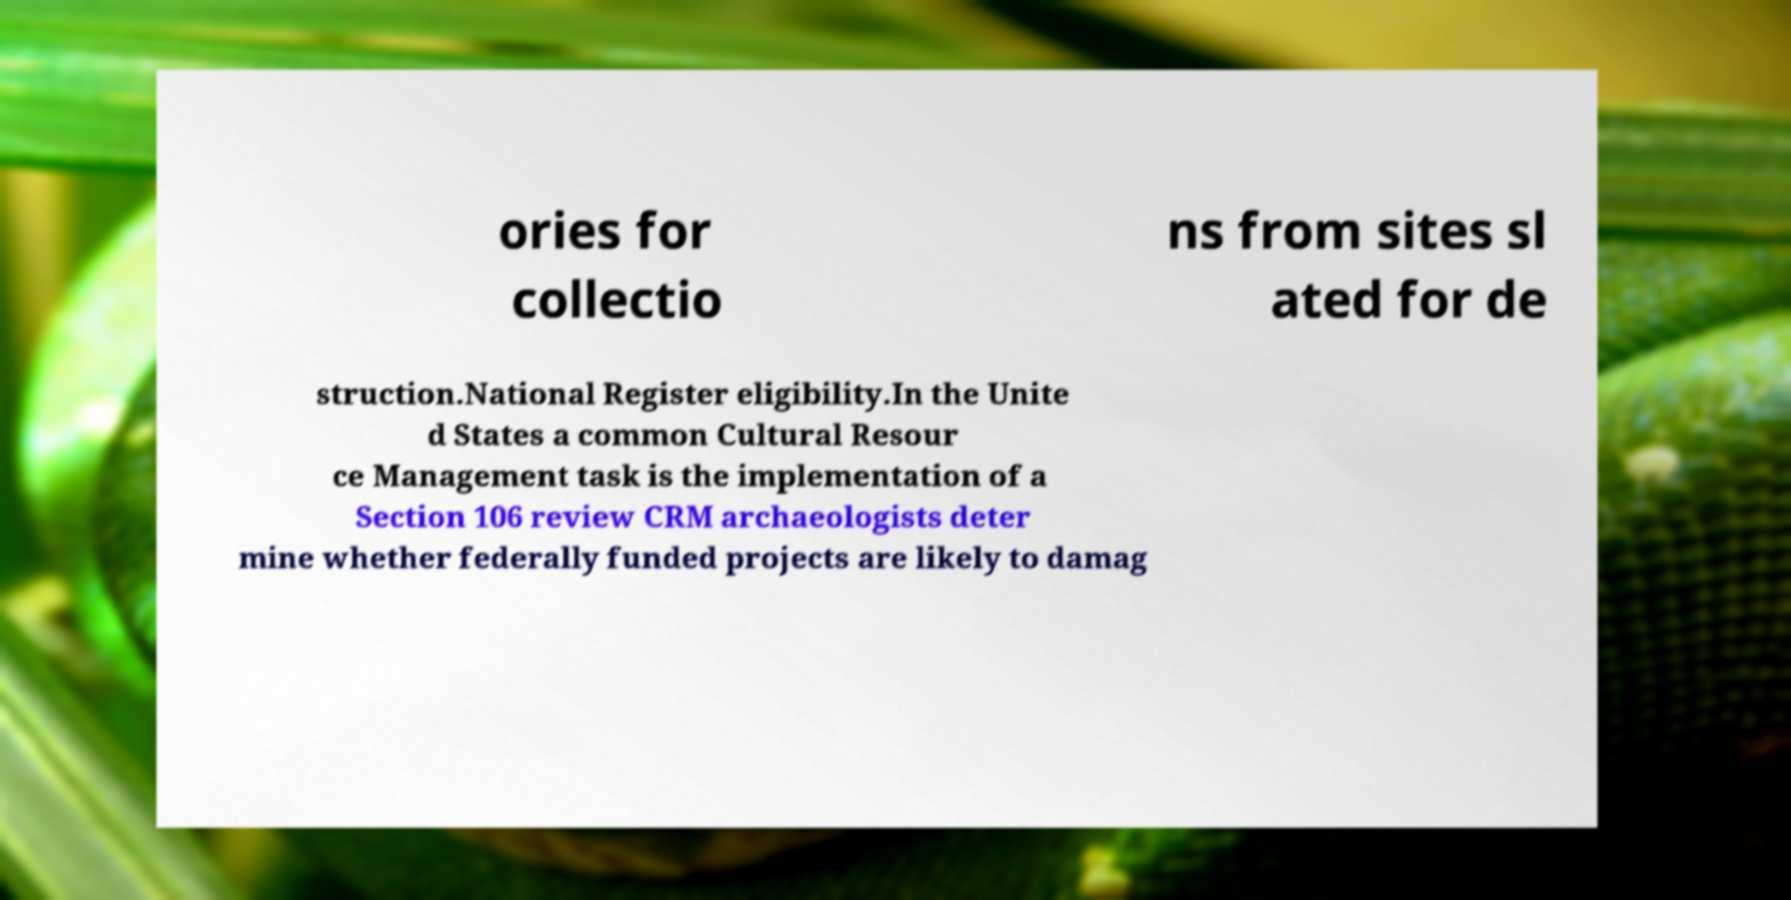Can you read and provide the text displayed in the image?This photo seems to have some interesting text. Can you extract and type it out for me? ories for collectio ns from sites sl ated for de struction.National Register eligibility.In the Unite d States a common Cultural Resour ce Management task is the implementation of a Section 106 review CRM archaeologists deter mine whether federally funded projects are likely to damag 